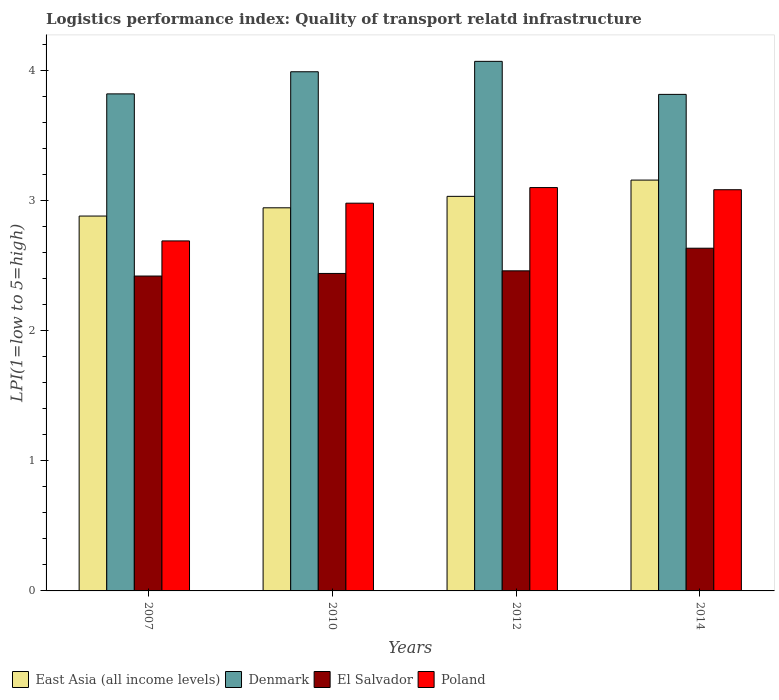How many different coloured bars are there?
Offer a very short reply. 4. Are the number of bars per tick equal to the number of legend labels?
Ensure brevity in your answer.  Yes. How many bars are there on the 1st tick from the right?
Offer a very short reply. 4. What is the label of the 1st group of bars from the left?
Your response must be concise. 2007. What is the logistics performance index in Denmark in 2007?
Your response must be concise. 3.82. Across all years, what is the maximum logistics performance index in El Salvador?
Give a very brief answer. 2.63. Across all years, what is the minimum logistics performance index in Denmark?
Offer a terse response. 3.82. What is the total logistics performance index in Poland in the graph?
Ensure brevity in your answer.  11.85. What is the difference between the logistics performance index in East Asia (all income levels) in 2007 and that in 2014?
Your answer should be compact. -0.28. What is the difference between the logistics performance index in Poland in 2007 and the logistics performance index in El Salvador in 2010?
Make the answer very short. 0.25. What is the average logistics performance index in East Asia (all income levels) per year?
Your response must be concise. 3. In the year 2007, what is the difference between the logistics performance index in Poland and logistics performance index in El Salvador?
Your answer should be compact. 0.27. In how many years, is the logistics performance index in East Asia (all income levels) greater than 3.2?
Ensure brevity in your answer.  0. What is the ratio of the logistics performance index in Poland in 2007 to that in 2010?
Your response must be concise. 0.9. What is the difference between the highest and the second highest logistics performance index in East Asia (all income levels)?
Keep it short and to the point. 0.12. What is the difference between the highest and the lowest logistics performance index in Poland?
Give a very brief answer. 0.41. Is it the case that in every year, the sum of the logistics performance index in Denmark and logistics performance index in El Salvador is greater than the sum of logistics performance index in East Asia (all income levels) and logistics performance index in Poland?
Give a very brief answer. Yes. What does the 3rd bar from the left in 2014 represents?
Your answer should be very brief. El Salvador. What does the 2nd bar from the right in 2012 represents?
Provide a succinct answer. El Salvador. How many bars are there?
Make the answer very short. 16. Are all the bars in the graph horizontal?
Keep it short and to the point. No. How many years are there in the graph?
Keep it short and to the point. 4. What is the difference between two consecutive major ticks on the Y-axis?
Your response must be concise. 1. Does the graph contain any zero values?
Offer a very short reply. No. Does the graph contain grids?
Your answer should be compact. No. How are the legend labels stacked?
Provide a succinct answer. Horizontal. What is the title of the graph?
Provide a short and direct response. Logistics performance index: Quality of transport relatd infrastructure. Does "Swaziland" appear as one of the legend labels in the graph?
Make the answer very short. No. What is the label or title of the Y-axis?
Give a very brief answer. LPI(1=low to 5=high). What is the LPI(1=low to 5=high) in East Asia (all income levels) in 2007?
Make the answer very short. 2.88. What is the LPI(1=low to 5=high) of Denmark in 2007?
Your answer should be very brief. 3.82. What is the LPI(1=low to 5=high) in El Salvador in 2007?
Provide a succinct answer. 2.42. What is the LPI(1=low to 5=high) of Poland in 2007?
Provide a short and direct response. 2.69. What is the LPI(1=low to 5=high) in East Asia (all income levels) in 2010?
Your answer should be compact. 2.94. What is the LPI(1=low to 5=high) of Denmark in 2010?
Your answer should be compact. 3.99. What is the LPI(1=low to 5=high) in El Salvador in 2010?
Make the answer very short. 2.44. What is the LPI(1=low to 5=high) of Poland in 2010?
Ensure brevity in your answer.  2.98. What is the LPI(1=low to 5=high) of East Asia (all income levels) in 2012?
Your response must be concise. 3.03. What is the LPI(1=low to 5=high) in Denmark in 2012?
Your response must be concise. 4.07. What is the LPI(1=low to 5=high) in El Salvador in 2012?
Give a very brief answer. 2.46. What is the LPI(1=low to 5=high) of East Asia (all income levels) in 2014?
Offer a terse response. 3.16. What is the LPI(1=low to 5=high) of Denmark in 2014?
Your answer should be compact. 3.82. What is the LPI(1=low to 5=high) of El Salvador in 2014?
Give a very brief answer. 2.63. What is the LPI(1=low to 5=high) in Poland in 2014?
Keep it short and to the point. 3.08. Across all years, what is the maximum LPI(1=low to 5=high) in East Asia (all income levels)?
Ensure brevity in your answer.  3.16. Across all years, what is the maximum LPI(1=low to 5=high) in Denmark?
Offer a terse response. 4.07. Across all years, what is the maximum LPI(1=low to 5=high) in El Salvador?
Your answer should be compact. 2.63. Across all years, what is the minimum LPI(1=low to 5=high) of East Asia (all income levels)?
Make the answer very short. 2.88. Across all years, what is the minimum LPI(1=low to 5=high) in Denmark?
Your answer should be very brief. 3.82. Across all years, what is the minimum LPI(1=low to 5=high) in El Salvador?
Provide a short and direct response. 2.42. Across all years, what is the minimum LPI(1=low to 5=high) of Poland?
Your answer should be very brief. 2.69. What is the total LPI(1=low to 5=high) in East Asia (all income levels) in the graph?
Your answer should be very brief. 12.02. What is the total LPI(1=low to 5=high) in Denmark in the graph?
Ensure brevity in your answer.  15.7. What is the total LPI(1=low to 5=high) in El Salvador in the graph?
Provide a short and direct response. 9.95. What is the total LPI(1=low to 5=high) in Poland in the graph?
Provide a short and direct response. 11.85. What is the difference between the LPI(1=low to 5=high) of East Asia (all income levels) in 2007 and that in 2010?
Provide a short and direct response. -0.06. What is the difference between the LPI(1=low to 5=high) of Denmark in 2007 and that in 2010?
Your answer should be compact. -0.17. What is the difference between the LPI(1=low to 5=high) of El Salvador in 2007 and that in 2010?
Offer a very short reply. -0.02. What is the difference between the LPI(1=low to 5=high) in Poland in 2007 and that in 2010?
Offer a terse response. -0.29. What is the difference between the LPI(1=low to 5=high) in East Asia (all income levels) in 2007 and that in 2012?
Your response must be concise. -0.15. What is the difference between the LPI(1=low to 5=high) in Denmark in 2007 and that in 2012?
Provide a succinct answer. -0.25. What is the difference between the LPI(1=low to 5=high) in El Salvador in 2007 and that in 2012?
Provide a succinct answer. -0.04. What is the difference between the LPI(1=low to 5=high) of Poland in 2007 and that in 2012?
Keep it short and to the point. -0.41. What is the difference between the LPI(1=low to 5=high) in East Asia (all income levels) in 2007 and that in 2014?
Offer a terse response. -0.28. What is the difference between the LPI(1=low to 5=high) in Denmark in 2007 and that in 2014?
Your response must be concise. 0. What is the difference between the LPI(1=low to 5=high) in El Salvador in 2007 and that in 2014?
Ensure brevity in your answer.  -0.21. What is the difference between the LPI(1=low to 5=high) in Poland in 2007 and that in 2014?
Make the answer very short. -0.39. What is the difference between the LPI(1=low to 5=high) of East Asia (all income levels) in 2010 and that in 2012?
Your answer should be compact. -0.09. What is the difference between the LPI(1=low to 5=high) of Denmark in 2010 and that in 2012?
Keep it short and to the point. -0.08. What is the difference between the LPI(1=low to 5=high) in El Salvador in 2010 and that in 2012?
Your answer should be very brief. -0.02. What is the difference between the LPI(1=low to 5=high) in Poland in 2010 and that in 2012?
Your answer should be compact. -0.12. What is the difference between the LPI(1=low to 5=high) of East Asia (all income levels) in 2010 and that in 2014?
Your answer should be compact. -0.21. What is the difference between the LPI(1=low to 5=high) of Denmark in 2010 and that in 2014?
Offer a very short reply. 0.17. What is the difference between the LPI(1=low to 5=high) of El Salvador in 2010 and that in 2014?
Ensure brevity in your answer.  -0.19. What is the difference between the LPI(1=low to 5=high) in Poland in 2010 and that in 2014?
Give a very brief answer. -0.1. What is the difference between the LPI(1=low to 5=high) in East Asia (all income levels) in 2012 and that in 2014?
Provide a short and direct response. -0.12. What is the difference between the LPI(1=low to 5=high) in Denmark in 2012 and that in 2014?
Offer a very short reply. 0.25. What is the difference between the LPI(1=low to 5=high) of El Salvador in 2012 and that in 2014?
Ensure brevity in your answer.  -0.17. What is the difference between the LPI(1=low to 5=high) in Poland in 2012 and that in 2014?
Offer a very short reply. 0.02. What is the difference between the LPI(1=low to 5=high) in East Asia (all income levels) in 2007 and the LPI(1=low to 5=high) in Denmark in 2010?
Give a very brief answer. -1.11. What is the difference between the LPI(1=low to 5=high) in East Asia (all income levels) in 2007 and the LPI(1=low to 5=high) in El Salvador in 2010?
Your answer should be compact. 0.44. What is the difference between the LPI(1=low to 5=high) in East Asia (all income levels) in 2007 and the LPI(1=low to 5=high) in Poland in 2010?
Offer a terse response. -0.1. What is the difference between the LPI(1=low to 5=high) in Denmark in 2007 and the LPI(1=low to 5=high) in El Salvador in 2010?
Ensure brevity in your answer.  1.38. What is the difference between the LPI(1=low to 5=high) of Denmark in 2007 and the LPI(1=low to 5=high) of Poland in 2010?
Your answer should be very brief. 0.84. What is the difference between the LPI(1=low to 5=high) in El Salvador in 2007 and the LPI(1=low to 5=high) in Poland in 2010?
Provide a short and direct response. -0.56. What is the difference between the LPI(1=low to 5=high) of East Asia (all income levels) in 2007 and the LPI(1=low to 5=high) of Denmark in 2012?
Make the answer very short. -1.19. What is the difference between the LPI(1=low to 5=high) of East Asia (all income levels) in 2007 and the LPI(1=low to 5=high) of El Salvador in 2012?
Provide a short and direct response. 0.42. What is the difference between the LPI(1=low to 5=high) in East Asia (all income levels) in 2007 and the LPI(1=low to 5=high) in Poland in 2012?
Ensure brevity in your answer.  -0.22. What is the difference between the LPI(1=low to 5=high) of Denmark in 2007 and the LPI(1=low to 5=high) of El Salvador in 2012?
Offer a terse response. 1.36. What is the difference between the LPI(1=low to 5=high) of Denmark in 2007 and the LPI(1=low to 5=high) of Poland in 2012?
Your answer should be compact. 0.72. What is the difference between the LPI(1=low to 5=high) of El Salvador in 2007 and the LPI(1=low to 5=high) of Poland in 2012?
Provide a succinct answer. -0.68. What is the difference between the LPI(1=low to 5=high) in East Asia (all income levels) in 2007 and the LPI(1=low to 5=high) in Denmark in 2014?
Provide a succinct answer. -0.94. What is the difference between the LPI(1=low to 5=high) in East Asia (all income levels) in 2007 and the LPI(1=low to 5=high) in El Salvador in 2014?
Offer a terse response. 0.25. What is the difference between the LPI(1=low to 5=high) in East Asia (all income levels) in 2007 and the LPI(1=low to 5=high) in Poland in 2014?
Give a very brief answer. -0.2. What is the difference between the LPI(1=low to 5=high) of Denmark in 2007 and the LPI(1=low to 5=high) of El Salvador in 2014?
Your answer should be compact. 1.19. What is the difference between the LPI(1=low to 5=high) in Denmark in 2007 and the LPI(1=low to 5=high) in Poland in 2014?
Your response must be concise. 0.74. What is the difference between the LPI(1=low to 5=high) in El Salvador in 2007 and the LPI(1=low to 5=high) in Poland in 2014?
Offer a very short reply. -0.66. What is the difference between the LPI(1=low to 5=high) in East Asia (all income levels) in 2010 and the LPI(1=low to 5=high) in Denmark in 2012?
Your response must be concise. -1.13. What is the difference between the LPI(1=low to 5=high) of East Asia (all income levels) in 2010 and the LPI(1=low to 5=high) of El Salvador in 2012?
Keep it short and to the point. 0.48. What is the difference between the LPI(1=low to 5=high) in East Asia (all income levels) in 2010 and the LPI(1=low to 5=high) in Poland in 2012?
Your answer should be compact. -0.16. What is the difference between the LPI(1=low to 5=high) in Denmark in 2010 and the LPI(1=low to 5=high) in El Salvador in 2012?
Provide a succinct answer. 1.53. What is the difference between the LPI(1=low to 5=high) of Denmark in 2010 and the LPI(1=low to 5=high) of Poland in 2012?
Give a very brief answer. 0.89. What is the difference between the LPI(1=low to 5=high) of El Salvador in 2010 and the LPI(1=low to 5=high) of Poland in 2012?
Make the answer very short. -0.66. What is the difference between the LPI(1=low to 5=high) of East Asia (all income levels) in 2010 and the LPI(1=low to 5=high) of Denmark in 2014?
Your response must be concise. -0.87. What is the difference between the LPI(1=low to 5=high) in East Asia (all income levels) in 2010 and the LPI(1=low to 5=high) in El Salvador in 2014?
Offer a terse response. 0.31. What is the difference between the LPI(1=low to 5=high) of East Asia (all income levels) in 2010 and the LPI(1=low to 5=high) of Poland in 2014?
Provide a short and direct response. -0.14. What is the difference between the LPI(1=low to 5=high) in Denmark in 2010 and the LPI(1=low to 5=high) in El Salvador in 2014?
Provide a short and direct response. 1.36. What is the difference between the LPI(1=low to 5=high) in Denmark in 2010 and the LPI(1=low to 5=high) in Poland in 2014?
Provide a short and direct response. 0.91. What is the difference between the LPI(1=low to 5=high) in El Salvador in 2010 and the LPI(1=low to 5=high) in Poland in 2014?
Ensure brevity in your answer.  -0.64. What is the difference between the LPI(1=low to 5=high) in East Asia (all income levels) in 2012 and the LPI(1=low to 5=high) in Denmark in 2014?
Ensure brevity in your answer.  -0.78. What is the difference between the LPI(1=low to 5=high) in East Asia (all income levels) in 2012 and the LPI(1=low to 5=high) in El Salvador in 2014?
Your response must be concise. 0.4. What is the difference between the LPI(1=low to 5=high) in East Asia (all income levels) in 2012 and the LPI(1=low to 5=high) in Poland in 2014?
Offer a terse response. -0.05. What is the difference between the LPI(1=low to 5=high) in Denmark in 2012 and the LPI(1=low to 5=high) in El Salvador in 2014?
Make the answer very short. 1.44. What is the difference between the LPI(1=low to 5=high) of Denmark in 2012 and the LPI(1=low to 5=high) of Poland in 2014?
Your answer should be compact. 0.99. What is the difference between the LPI(1=low to 5=high) in El Salvador in 2012 and the LPI(1=low to 5=high) in Poland in 2014?
Provide a succinct answer. -0.62. What is the average LPI(1=low to 5=high) of East Asia (all income levels) per year?
Keep it short and to the point. 3. What is the average LPI(1=low to 5=high) in Denmark per year?
Your answer should be very brief. 3.92. What is the average LPI(1=low to 5=high) of El Salvador per year?
Keep it short and to the point. 2.49. What is the average LPI(1=low to 5=high) of Poland per year?
Offer a terse response. 2.96. In the year 2007, what is the difference between the LPI(1=low to 5=high) in East Asia (all income levels) and LPI(1=low to 5=high) in Denmark?
Ensure brevity in your answer.  -0.94. In the year 2007, what is the difference between the LPI(1=low to 5=high) in East Asia (all income levels) and LPI(1=low to 5=high) in El Salvador?
Offer a terse response. 0.46. In the year 2007, what is the difference between the LPI(1=low to 5=high) in East Asia (all income levels) and LPI(1=low to 5=high) in Poland?
Your answer should be very brief. 0.19. In the year 2007, what is the difference between the LPI(1=low to 5=high) of Denmark and LPI(1=low to 5=high) of Poland?
Provide a succinct answer. 1.13. In the year 2007, what is the difference between the LPI(1=low to 5=high) in El Salvador and LPI(1=low to 5=high) in Poland?
Your response must be concise. -0.27. In the year 2010, what is the difference between the LPI(1=low to 5=high) in East Asia (all income levels) and LPI(1=low to 5=high) in Denmark?
Provide a short and direct response. -1.05. In the year 2010, what is the difference between the LPI(1=low to 5=high) in East Asia (all income levels) and LPI(1=low to 5=high) in El Salvador?
Your answer should be compact. 0.5. In the year 2010, what is the difference between the LPI(1=low to 5=high) in East Asia (all income levels) and LPI(1=low to 5=high) in Poland?
Offer a terse response. -0.04. In the year 2010, what is the difference between the LPI(1=low to 5=high) in Denmark and LPI(1=low to 5=high) in El Salvador?
Keep it short and to the point. 1.55. In the year 2010, what is the difference between the LPI(1=low to 5=high) of El Salvador and LPI(1=low to 5=high) of Poland?
Ensure brevity in your answer.  -0.54. In the year 2012, what is the difference between the LPI(1=low to 5=high) of East Asia (all income levels) and LPI(1=low to 5=high) of Denmark?
Your answer should be very brief. -1.04. In the year 2012, what is the difference between the LPI(1=low to 5=high) in East Asia (all income levels) and LPI(1=low to 5=high) in El Salvador?
Provide a short and direct response. 0.57. In the year 2012, what is the difference between the LPI(1=low to 5=high) of East Asia (all income levels) and LPI(1=low to 5=high) of Poland?
Your response must be concise. -0.07. In the year 2012, what is the difference between the LPI(1=low to 5=high) of Denmark and LPI(1=low to 5=high) of El Salvador?
Keep it short and to the point. 1.61. In the year 2012, what is the difference between the LPI(1=low to 5=high) of El Salvador and LPI(1=low to 5=high) of Poland?
Your answer should be compact. -0.64. In the year 2014, what is the difference between the LPI(1=low to 5=high) of East Asia (all income levels) and LPI(1=low to 5=high) of Denmark?
Your answer should be very brief. -0.66. In the year 2014, what is the difference between the LPI(1=low to 5=high) of East Asia (all income levels) and LPI(1=low to 5=high) of El Salvador?
Offer a very short reply. 0.52. In the year 2014, what is the difference between the LPI(1=low to 5=high) of East Asia (all income levels) and LPI(1=low to 5=high) of Poland?
Keep it short and to the point. 0.07. In the year 2014, what is the difference between the LPI(1=low to 5=high) of Denmark and LPI(1=low to 5=high) of El Salvador?
Your answer should be very brief. 1.18. In the year 2014, what is the difference between the LPI(1=low to 5=high) of Denmark and LPI(1=low to 5=high) of Poland?
Your answer should be very brief. 0.73. In the year 2014, what is the difference between the LPI(1=low to 5=high) in El Salvador and LPI(1=low to 5=high) in Poland?
Provide a short and direct response. -0.45. What is the ratio of the LPI(1=low to 5=high) of East Asia (all income levels) in 2007 to that in 2010?
Give a very brief answer. 0.98. What is the ratio of the LPI(1=low to 5=high) of Denmark in 2007 to that in 2010?
Give a very brief answer. 0.96. What is the ratio of the LPI(1=low to 5=high) of El Salvador in 2007 to that in 2010?
Ensure brevity in your answer.  0.99. What is the ratio of the LPI(1=low to 5=high) of Poland in 2007 to that in 2010?
Make the answer very short. 0.9. What is the ratio of the LPI(1=low to 5=high) of East Asia (all income levels) in 2007 to that in 2012?
Give a very brief answer. 0.95. What is the ratio of the LPI(1=low to 5=high) of Denmark in 2007 to that in 2012?
Make the answer very short. 0.94. What is the ratio of the LPI(1=low to 5=high) of El Salvador in 2007 to that in 2012?
Your response must be concise. 0.98. What is the ratio of the LPI(1=low to 5=high) in Poland in 2007 to that in 2012?
Make the answer very short. 0.87. What is the ratio of the LPI(1=low to 5=high) in East Asia (all income levels) in 2007 to that in 2014?
Your answer should be compact. 0.91. What is the ratio of the LPI(1=low to 5=high) in Denmark in 2007 to that in 2014?
Your response must be concise. 1. What is the ratio of the LPI(1=low to 5=high) of El Salvador in 2007 to that in 2014?
Your answer should be very brief. 0.92. What is the ratio of the LPI(1=low to 5=high) in Poland in 2007 to that in 2014?
Provide a succinct answer. 0.87. What is the ratio of the LPI(1=low to 5=high) of Denmark in 2010 to that in 2012?
Offer a terse response. 0.98. What is the ratio of the LPI(1=low to 5=high) in Poland in 2010 to that in 2012?
Give a very brief answer. 0.96. What is the ratio of the LPI(1=low to 5=high) of East Asia (all income levels) in 2010 to that in 2014?
Offer a terse response. 0.93. What is the ratio of the LPI(1=low to 5=high) in Denmark in 2010 to that in 2014?
Provide a succinct answer. 1.05. What is the ratio of the LPI(1=low to 5=high) of El Salvador in 2010 to that in 2014?
Provide a short and direct response. 0.93. What is the ratio of the LPI(1=low to 5=high) in Poland in 2010 to that in 2014?
Keep it short and to the point. 0.97. What is the ratio of the LPI(1=low to 5=high) of East Asia (all income levels) in 2012 to that in 2014?
Give a very brief answer. 0.96. What is the ratio of the LPI(1=low to 5=high) in Denmark in 2012 to that in 2014?
Your answer should be very brief. 1.07. What is the ratio of the LPI(1=low to 5=high) in El Salvador in 2012 to that in 2014?
Offer a terse response. 0.93. What is the ratio of the LPI(1=low to 5=high) of Poland in 2012 to that in 2014?
Provide a succinct answer. 1.01. What is the difference between the highest and the second highest LPI(1=low to 5=high) in Denmark?
Keep it short and to the point. 0.08. What is the difference between the highest and the second highest LPI(1=low to 5=high) in El Salvador?
Offer a terse response. 0.17. What is the difference between the highest and the second highest LPI(1=low to 5=high) in Poland?
Make the answer very short. 0.02. What is the difference between the highest and the lowest LPI(1=low to 5=high) of East Asia (all income levels)?
Offer a terse response. 0.28. What is the difference between the highest and the lowest LPI(1=low to 5=high) in Denmark?
Offer a terse response. 0.25. What is the difference between the highest and the lowest LPI(1=low to 5=high) of El Salvador?
Keep it short and to the point. 0.21. What is the difference between the highest and the lowest LPI(1=low to 5=high) of Poland?
Your response must be concise. 0.41. 